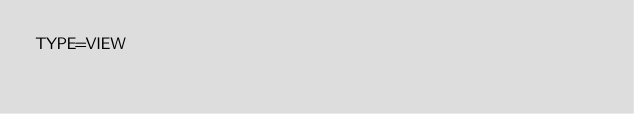Convert code to text. <code><loc_0><loc_0><loc_500><loc_500><_VisualBasic_>TYPE=VIEW</code> 